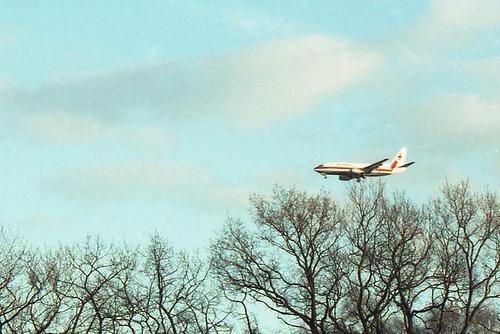How many airplanes are in the photograph?
Give a very brief answer. 1. 